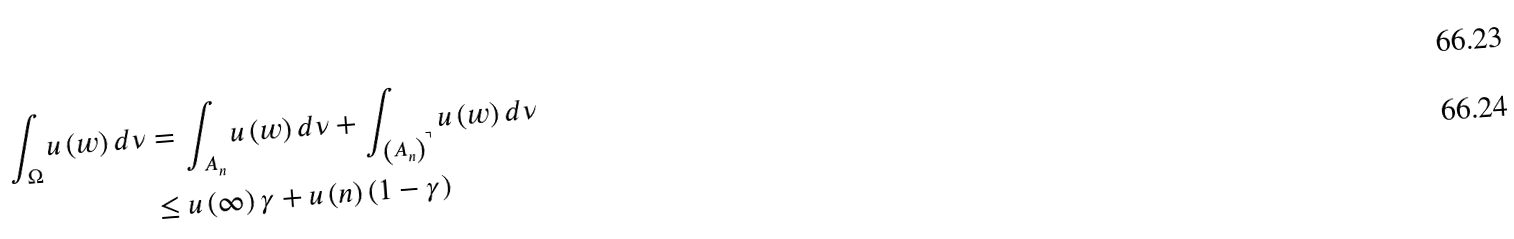Convert formula to latex. <formula><loc_0><loc_0><loc_500><loc_500>\int _ { \Omega } u \left ( w \right ) d \nu & = \int _ { A _ { n } } u \left ( w \right ) d \nu + \int _ { \left ( A _ { n } \right ) ^ { \urcorner } } u \left ( w \right ) d \nu \\ & \leq u \left ( \infty \right ) \gamma + u \left ( n \right ) \left ( 1 - \gamma \right )</formula> 